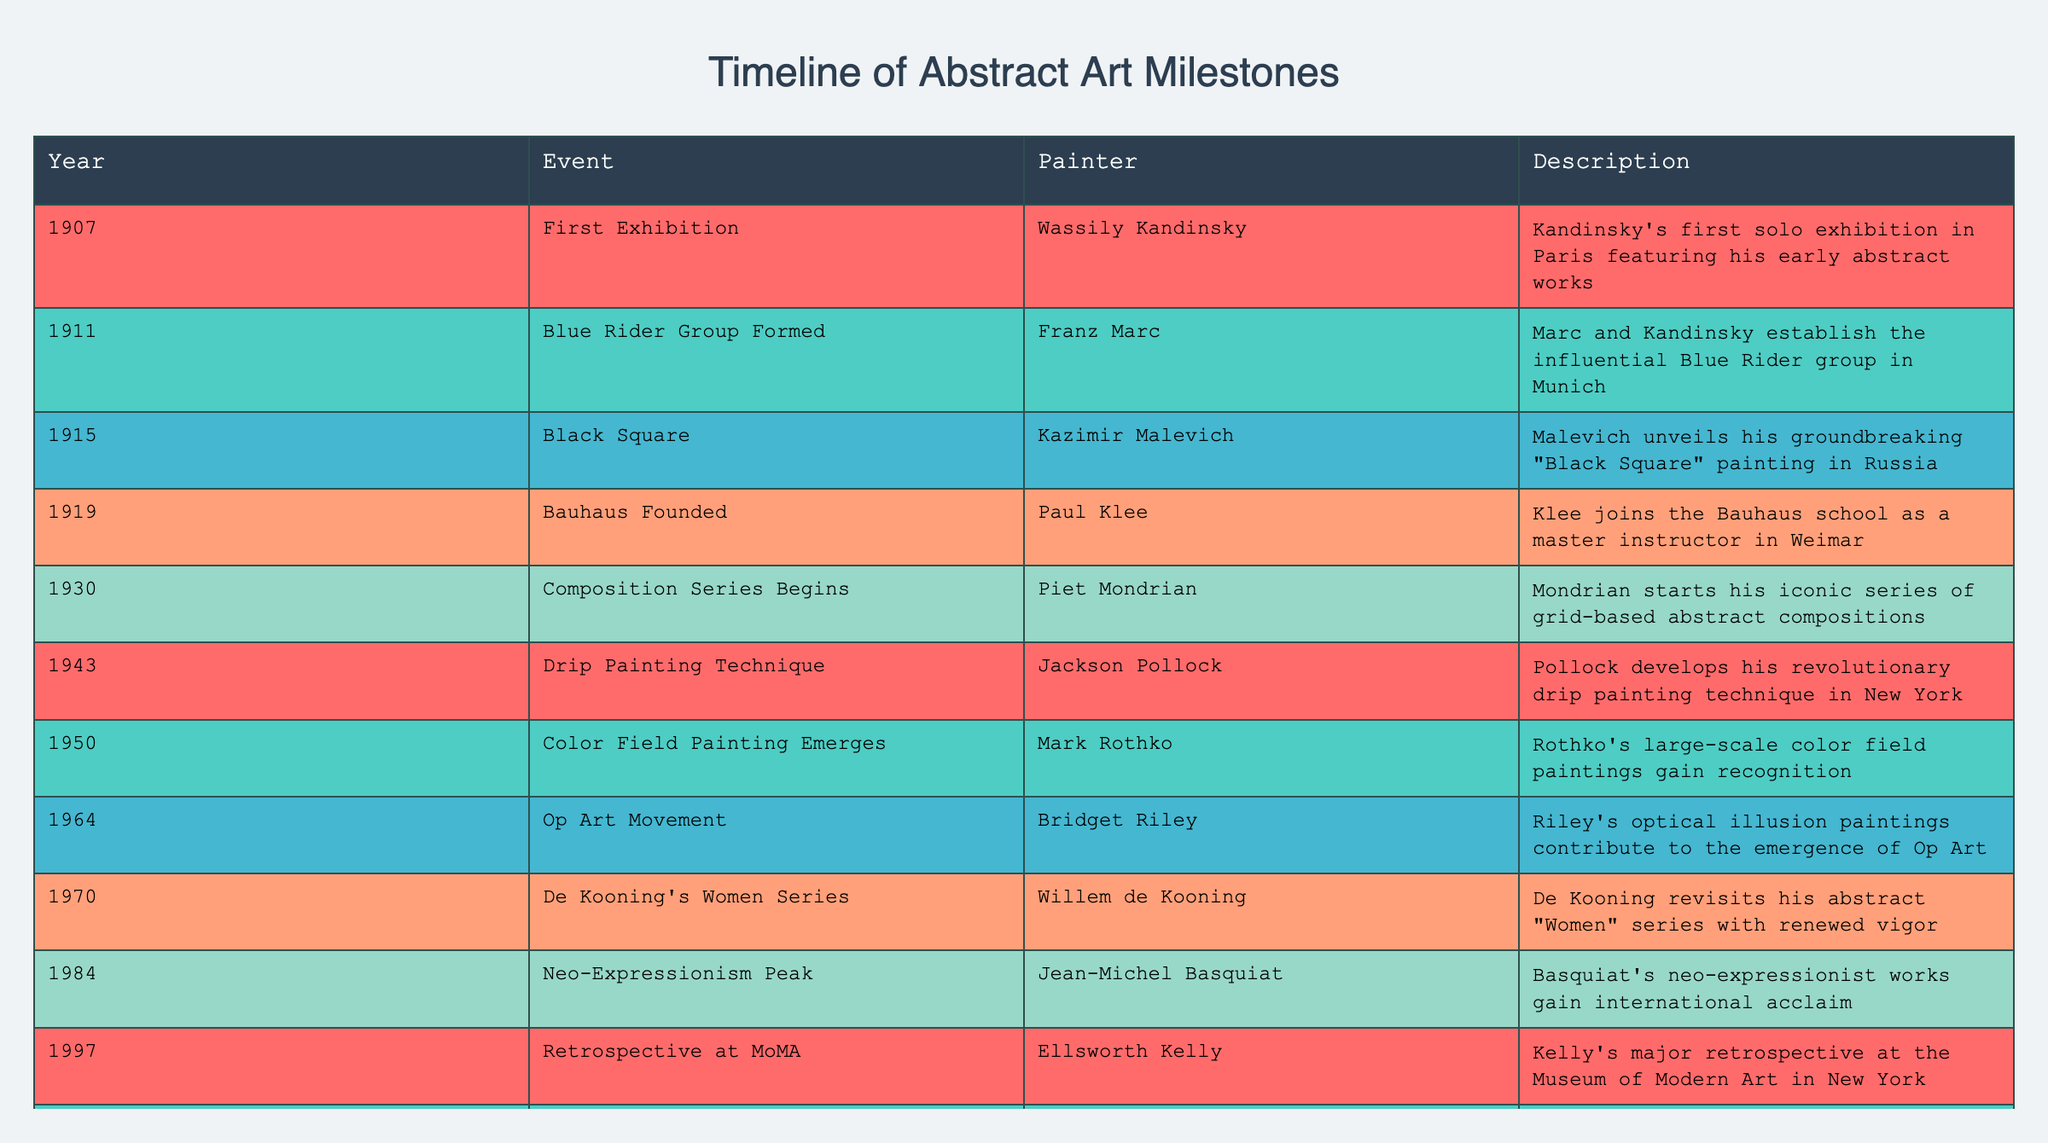What year did Kandinsky have his first solo exhibition? The table lists the year of significant events for various abstract painters. For Wassily Kandinsky, the "First Exhibition" occurred in 1907.
Answer: 1907 In which year did the Op Art movement gain prominence with Bridget Riley? From the table, Bridget Riley's contributions to the Op Art movement are noted to have occurred in 1964.
Answer: 1964 What is the difference in years between Malevich unveiling "Black Square" and Klee joining the Bauhaus? Malevich unveiled "Black Square" in 1915 and Klee joined Bauhaus in 1919. The difference is 1919 - 1915 = 4 years.
Answer: 4 years Did Rothko's large-scale color field paintings gain recognition before or after 1950? The table indicates that Rothko's recognition for color field paintings occurred in 1950. Thus, it is earlier or at the same time as 1950.
Answer: Before or at the same time as 1950 What significant event involving Dutch painter Piet Mondrian began in 1930? The table shows that in 1930, Mondrian began his "Composition Series," which is significant in his career as it outlines an iconic phase of his work.
Answer: Composition Series Begins 